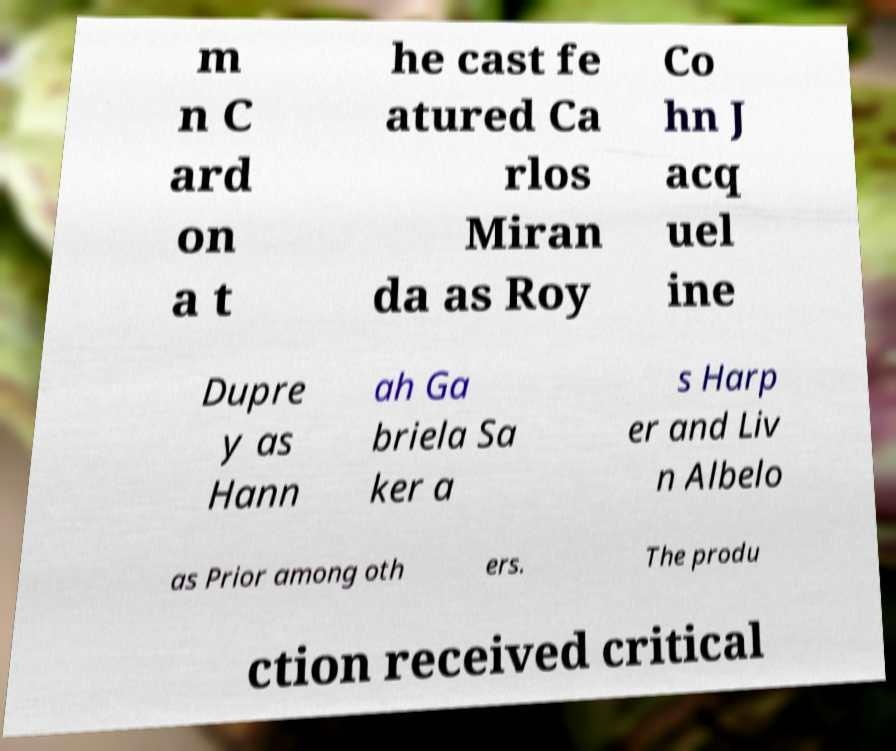Could you assist in decoding the text presented in this image and type it out clearly? m n C ard on a t he cast fe atured Ca rlos Miran da as Roy Co hn J acq uel ine Dupre y as Hann ah Ga briela Sa ker a s Harp er and Liv n Albelo as Prior among oth ers. The produ ction received critical 